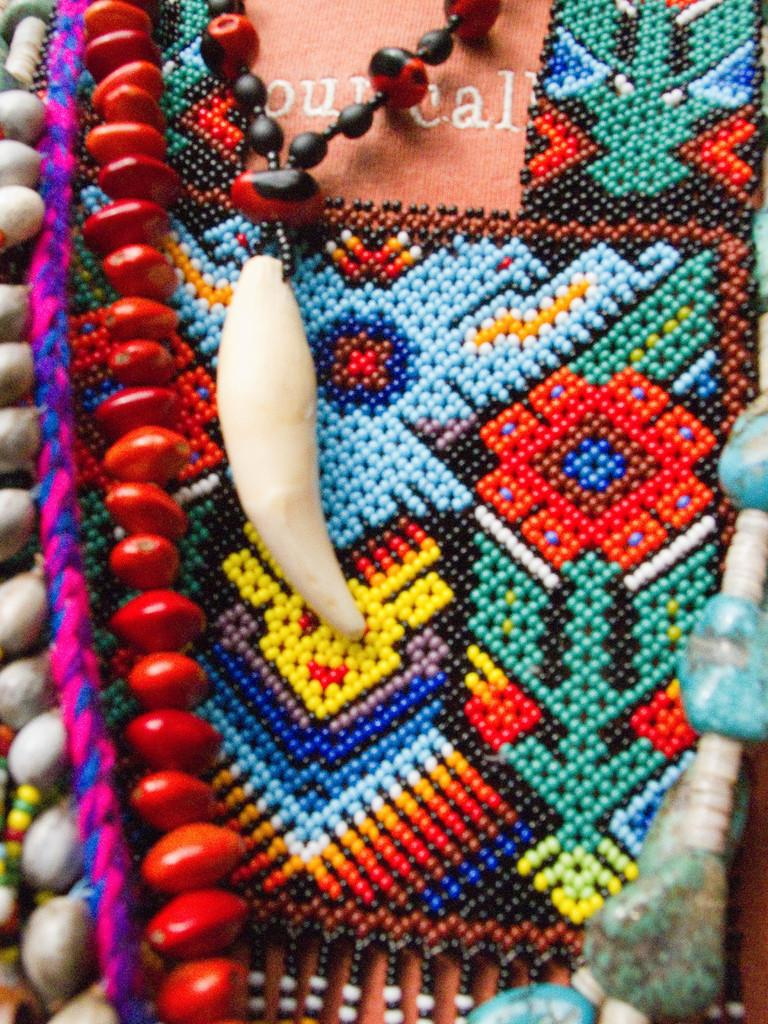What type of objects can be seen in the image? There are chains and craft in the image. Can you describe the chains in the image? The chains are the main objects visible in the image. What type of craft is depicted in the image? The craft in the image is not specified, but it is present alongside the chains. What type of machine is making noise in the image? There is no machine present in the image, and therefore no noise can be heard. How are the chains being sorted in the image? There is no indication of the chains being sorted in the image. 